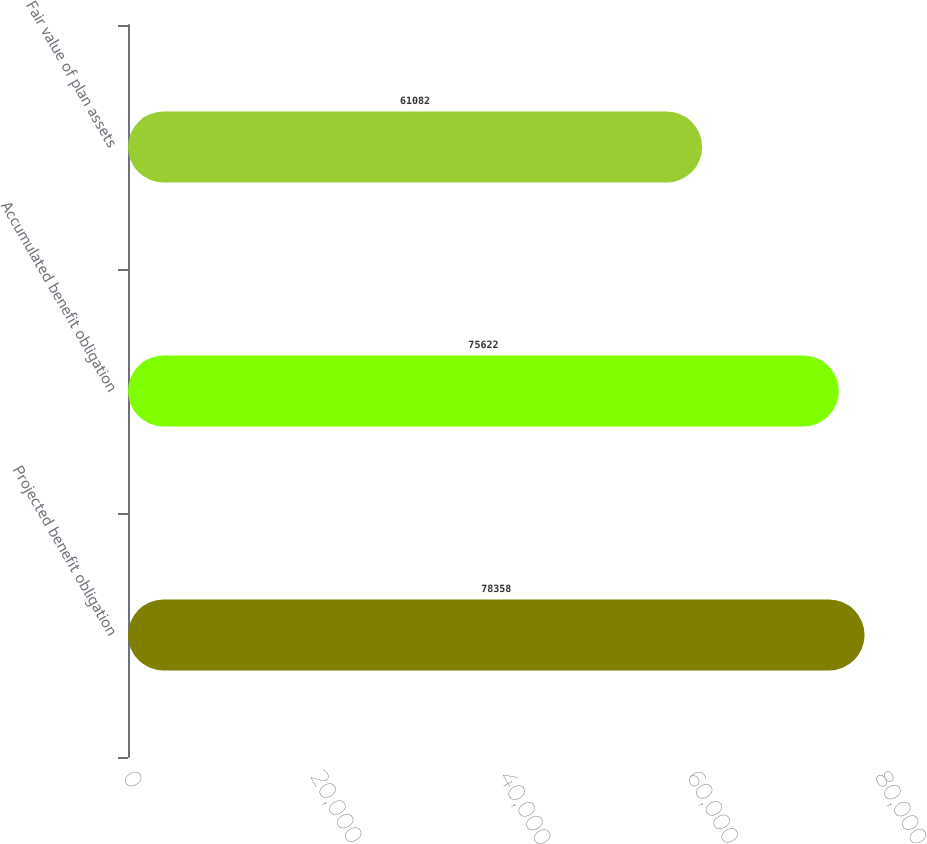Convert chart. <chart><loc_0><loc_0><loc_500><loc_500><bar_chart><fcel>Projected benefit obligation<fcel>Accumulated benefit obligation<fcel>Fair value of plan assets<nl><fcel>78358<fcel>75622<fcel>61082<nl></chart> 